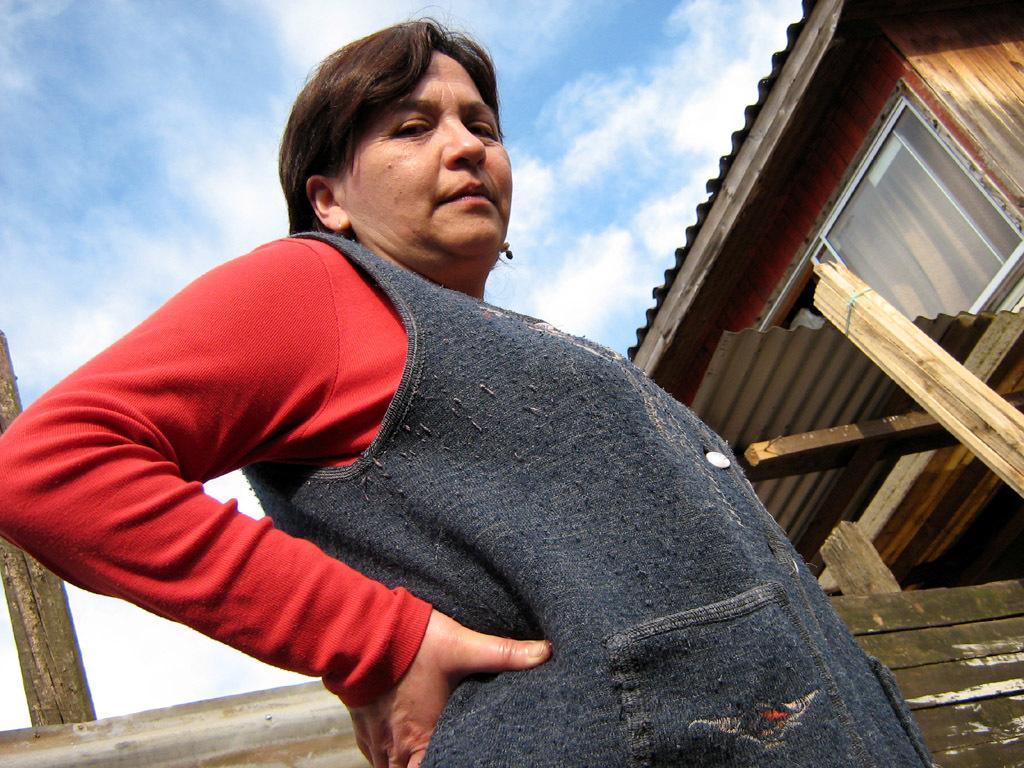How would you summarize this image in a sentence or two? In this image we can see a woman standing. On the backside we can see a house with roof, window and some wooden poles. We can also see the sky which looks cloudy. 